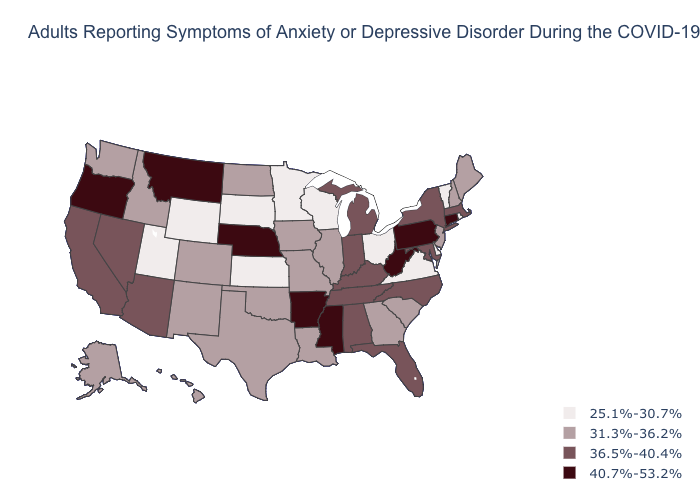Among the states that border Connecticut , does New York have the highest value?
Quick response, please. Yes. Is the legend a continuous bar?
Give a very brief answer. No. Among the states that border Massachusetts , does Connecticut have the highest value?
Answer briefly. Yes. Does Florida have the same value as Idaho?
Write a very short answer. No. What is the value of California?
Quick response, please. 36.5%-40.4%. What is the lowest value in states that border Kansas?
Quick response, please. 31.3%-36.2%. Does the map have missing data?
Quick response, please. No. Name the states that have a value in the range 36.5%-40.4%?
Quick response, please. Alabama, Arizona, California, Florida, Indiana, Kentucky, Maryland, Massachusetts, Michigan, Nevada, New York, North Carolina, Tennessee. What is the lowest value in the USA?
Be succinct. 25.1%-30.7%. Name the states that have a value in the range 40.7%-53.2%?
Concise answer only. Arkansas, Connecticut, Mississippi, Montana, Nebraska, Oregon, Pennsylvania, West Virginia. Which states have the highest value in the USA?
Be succinct. Arkansas, Connecticut, Mississippi, Montana, Nebraska, Oregon, Pennsylvania, West Virginia. What is the value of Hawaii?
Quick response, please. 31.3%-36.2%. Name the states that have a value in the range 25.1%-30.7%?
Quick response, please. Delaware, Kansas, Minnesota, Ohio, Rhode Island, South Dakota, Utah, Vermont, Virginia, Wisconsin, Wyoming. What is the highest value in the South ?
Write a very short answer. 40.7%-53.2%. What is the value of Vermont?
Answer briefly. 25.1%-30.7%. 